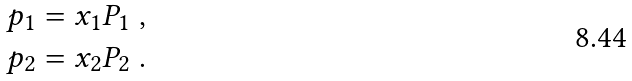Convert formula to latex. <formula><loc_0><loc_0><loc_500><loc_500>p _ { 1 } & = x _ { 1 } P _ { 1 } \ , \\ p _ { 2 } & = x _ { 2 } P _ { 2 } \ .</formula> 